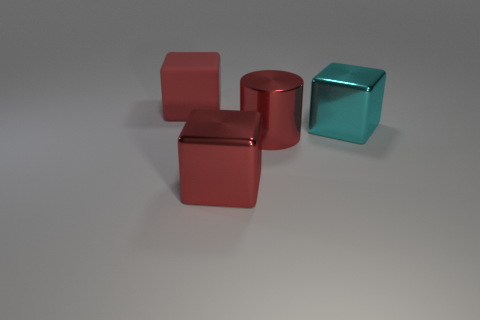Can you describe the texture and color differences between the objects? Certainly! The objects depicted vary in texture and color. On the left, there's a matte-finished object with a subdued sheen, signifying less light reflection. It's metallic gray, evoking a sense of practicality. In contrast, the three objects on the right shine with a glossy finish, two of them in shades of red and one in a turquoise hue. The red has a deep, lustrous quality, while the turquoise cube reflects light brightly, which altogether creates an intriguing visual contrast. 